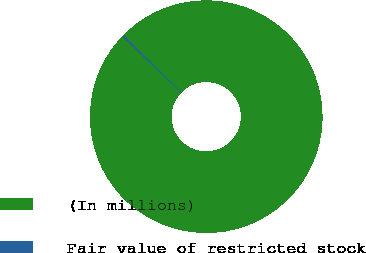Convert chart. <chart><loc_0><loc_0><loc_500><loc_500><pie_chart><fcel>(In millions)<fcel>Fair value of restricted stock<nl><fcel>99.74%<fcel>0.26%<nl></chart> 